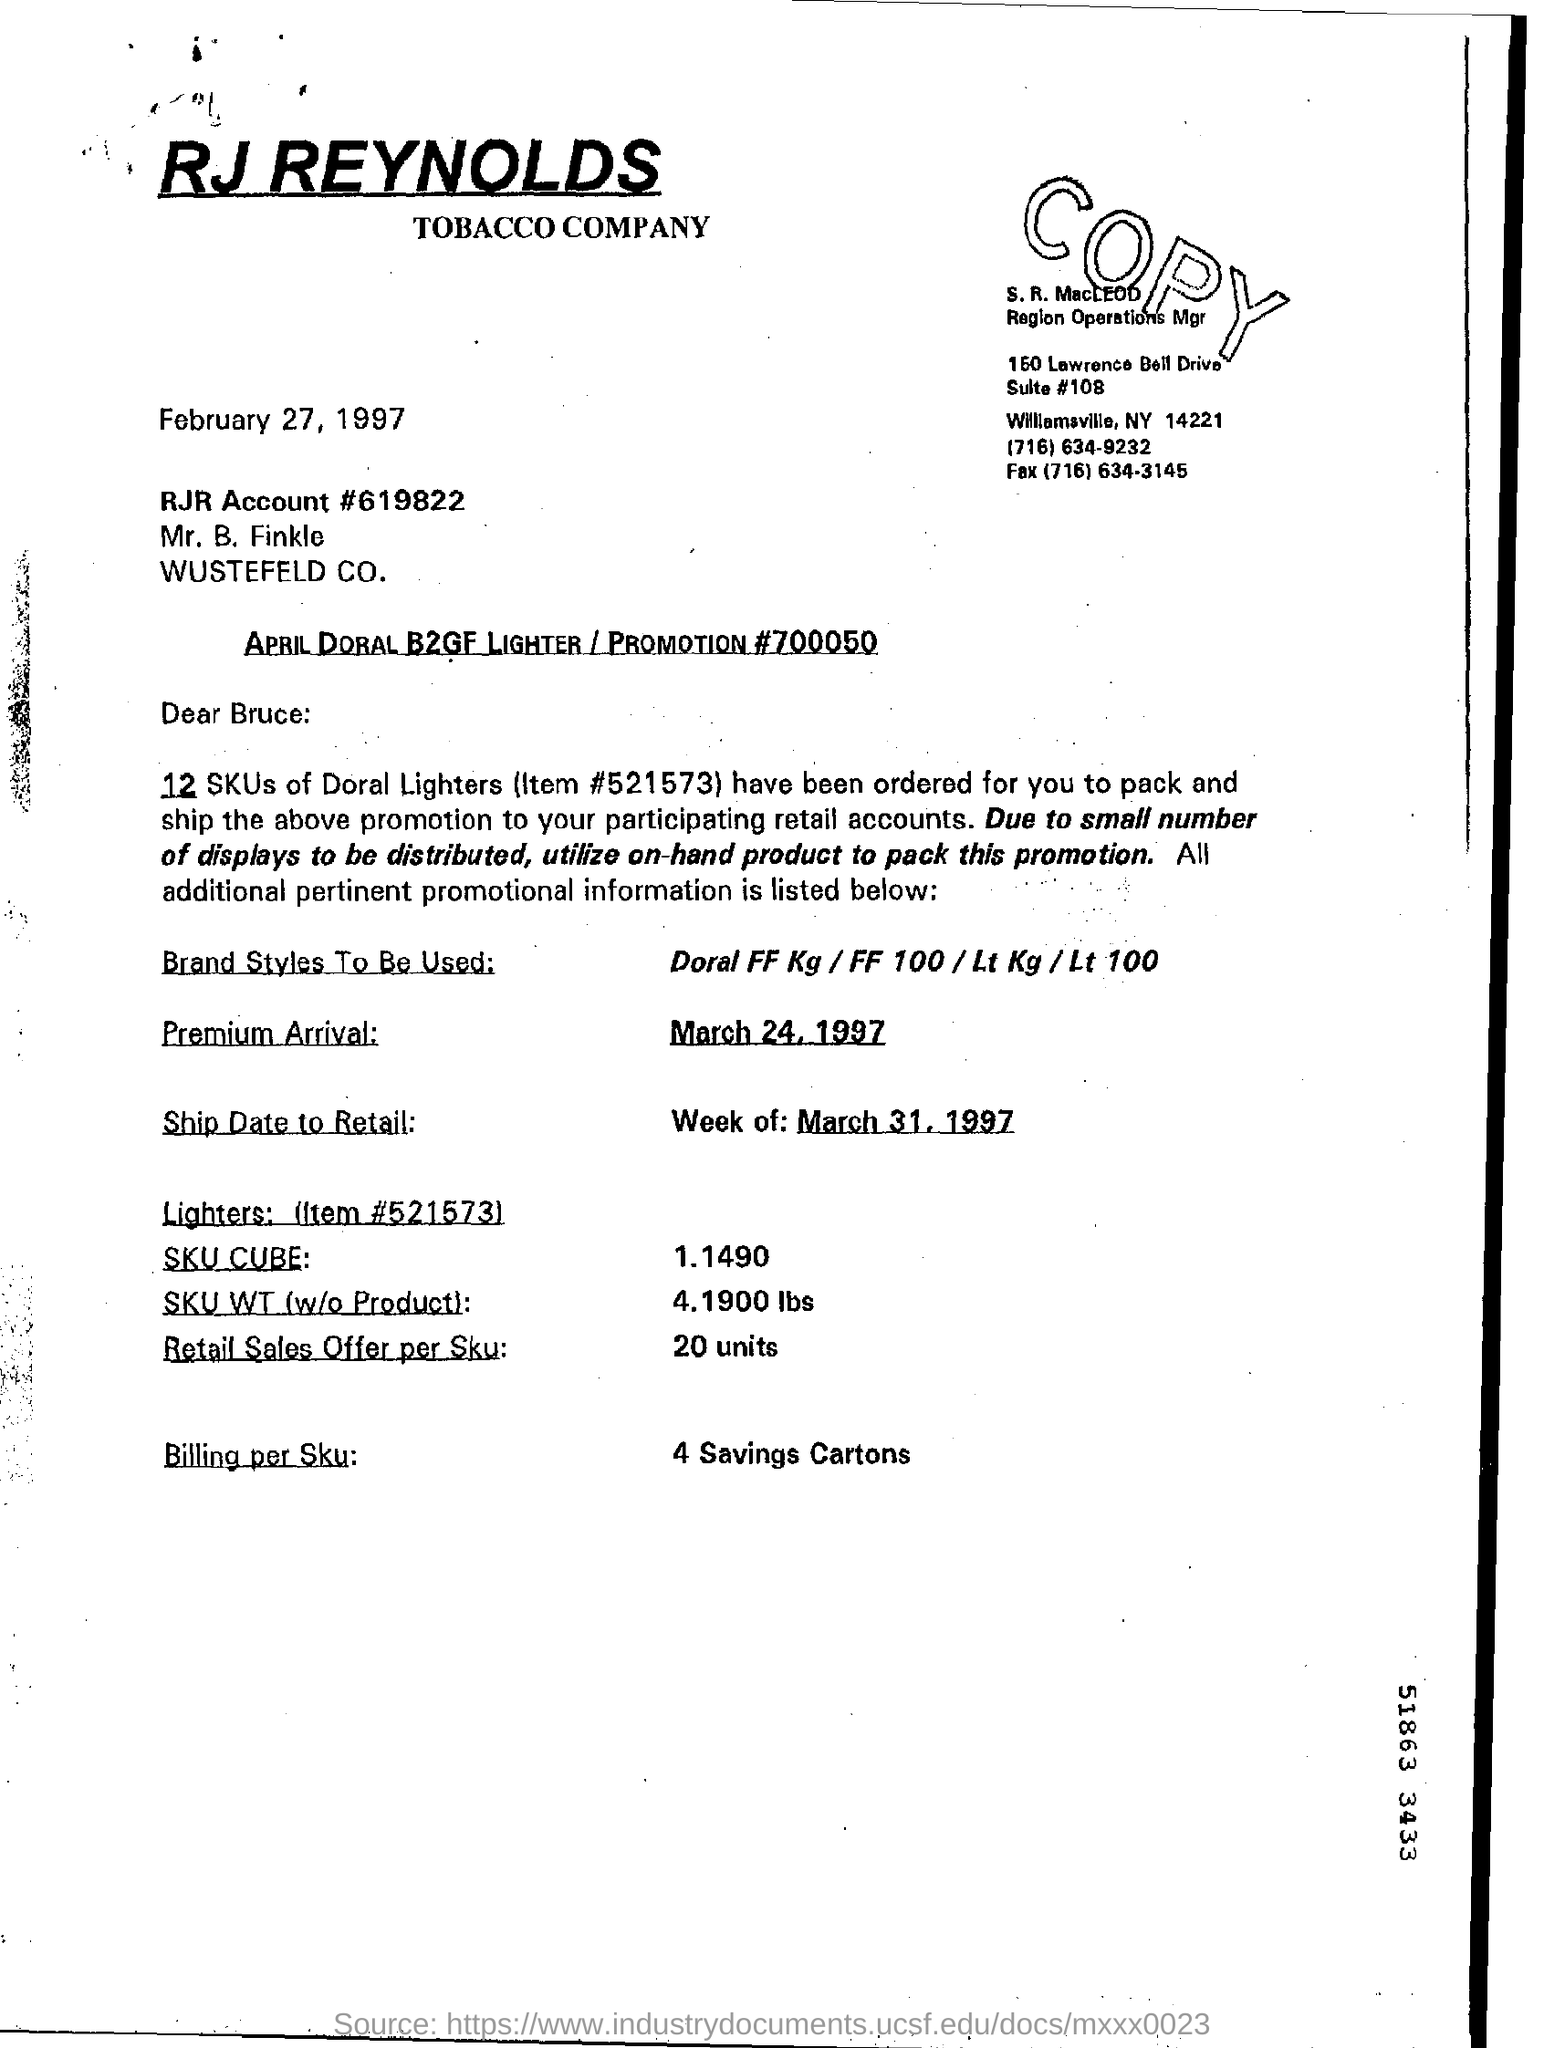Point out several critical features in this image. The Retail Sales Offer per Sku for 20 units is ... The item number for Doral Lighters is 521573... The premium arrival date is March 24, 1997. 